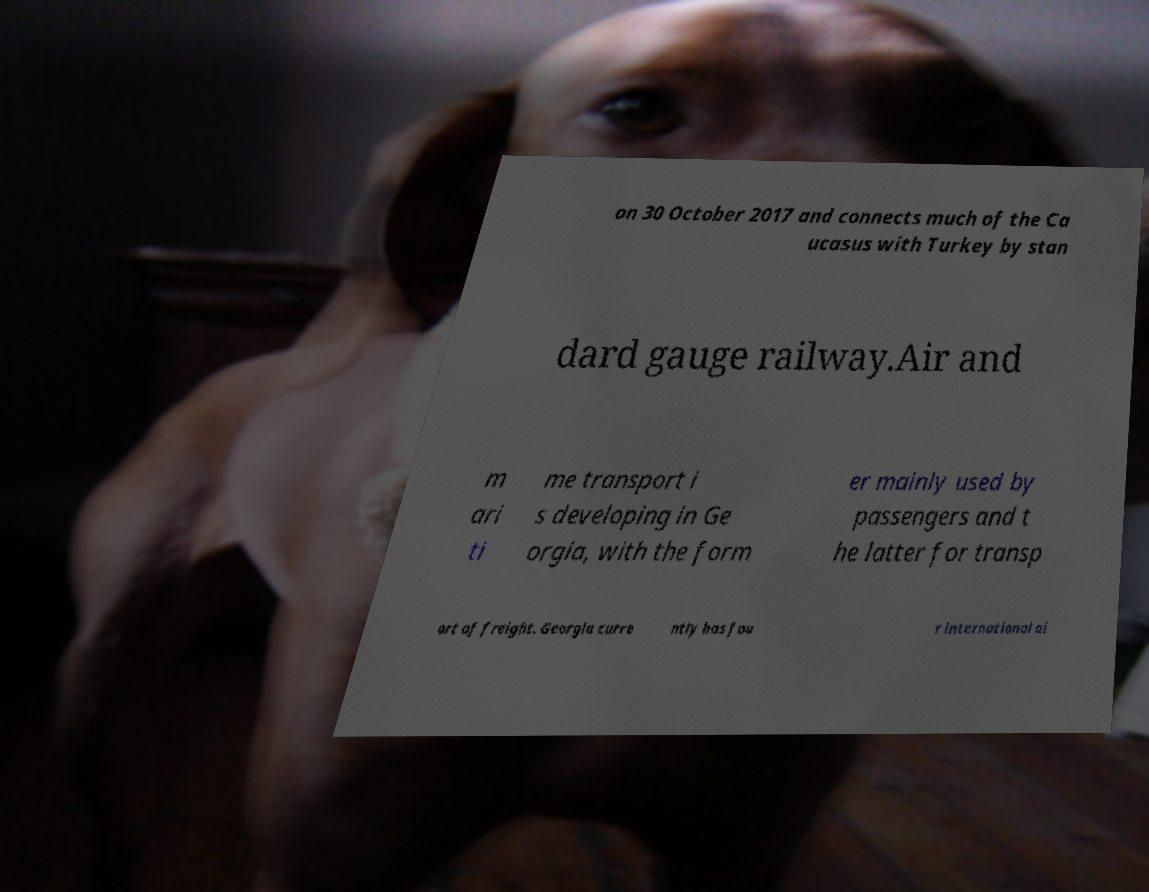For documentation purposes, I need the text within this image transcribed. Could you provide that? on 30 October 2017 and connects much of the Ca ucasus with Turkey by stan dard gauge railway.Air and m ari ti me transport i s developing in Ge orgia, with the form er mainly used by passengers and t he latter for transp ort of freight. Georgia curre ntly has fou r international ai 